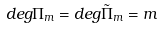<formula> <loc_0><loc_0><loc_500><loc_500>d e g \Pi _ { m } = d e g \tilde { \Pi } _ { m } = m</formula> 